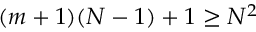Convert formula to latex. <formula><loc_0><loc_0><loc_500><loc_500>( m + 1 ) ( N - 1 ) + 1 \geq N ^ { 2 }</formula> 